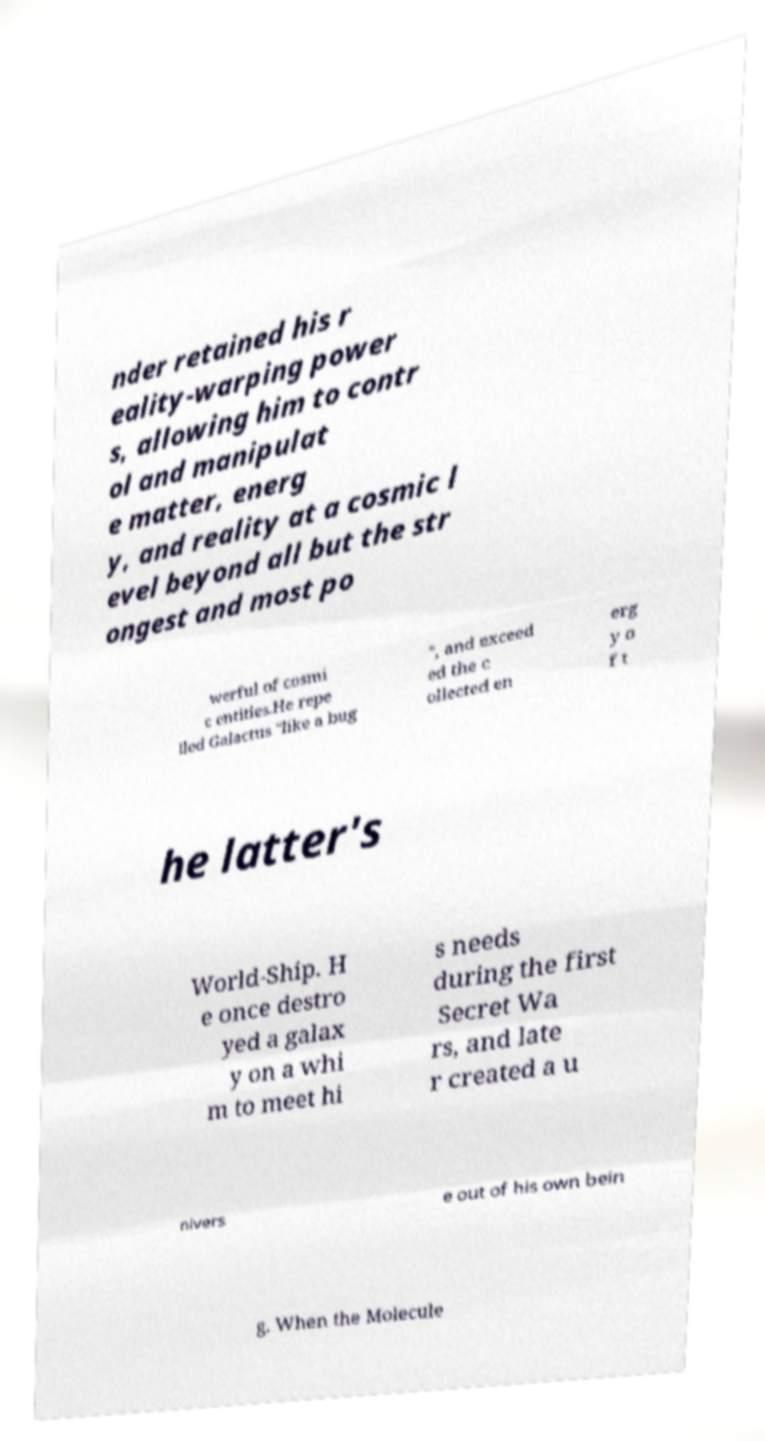Can you read and provide the text displayed in the image?This photo seems to have some interesting text. Can you extract and type it out for me? nder retained his r eality-warping power s, allowing him to contr ol and manipulat e matter, energ y, and reality at a cosmic l evel beyond all but the str ongest and most po werful of cosmi c entities.He repe lled Galactus "like a bug ", and exceed ed the c ollected en erg y o f t he latter's World-Ship. H e once destro yed a galax y on a whi m to meet hi s needs during the first Secret Wa rs, and late r created a u nivers e out of his own bein g. When the Molecule 